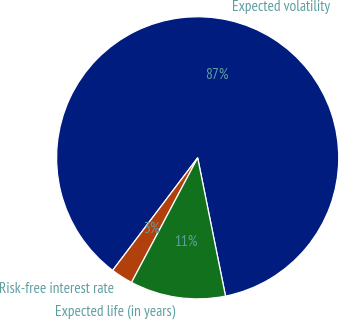Convert chart. <chart><loc_0><loc_0><loc_500><loc_500><pie_chart><fcel>Expected volatility<fcel>Risk-free interest rate<fcel>Expected life (in years)<nl><fcel>86.55%<fcel>2.53%<fcel>10.93%<nl></chart> 